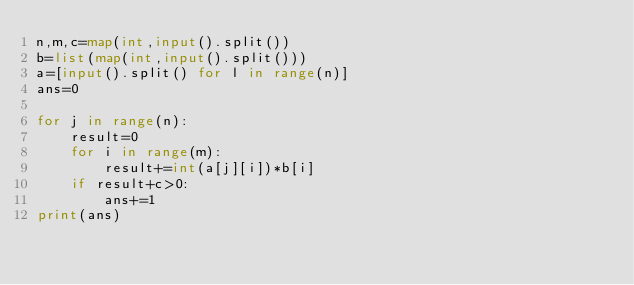<code> <loc_0><loc_0><loc_500><loc_500><_Python_>n,m,c=map(int,input().split())
b=list(map(int,input().split()))
a=[input().split() for l in range(n)]
ans=0

for j in range(n):
    result=0
    for i in range(m):
        result+=int(a[j][i])*b[i]
    if result+c>0:
        ans+=1
print(ans)</code> 